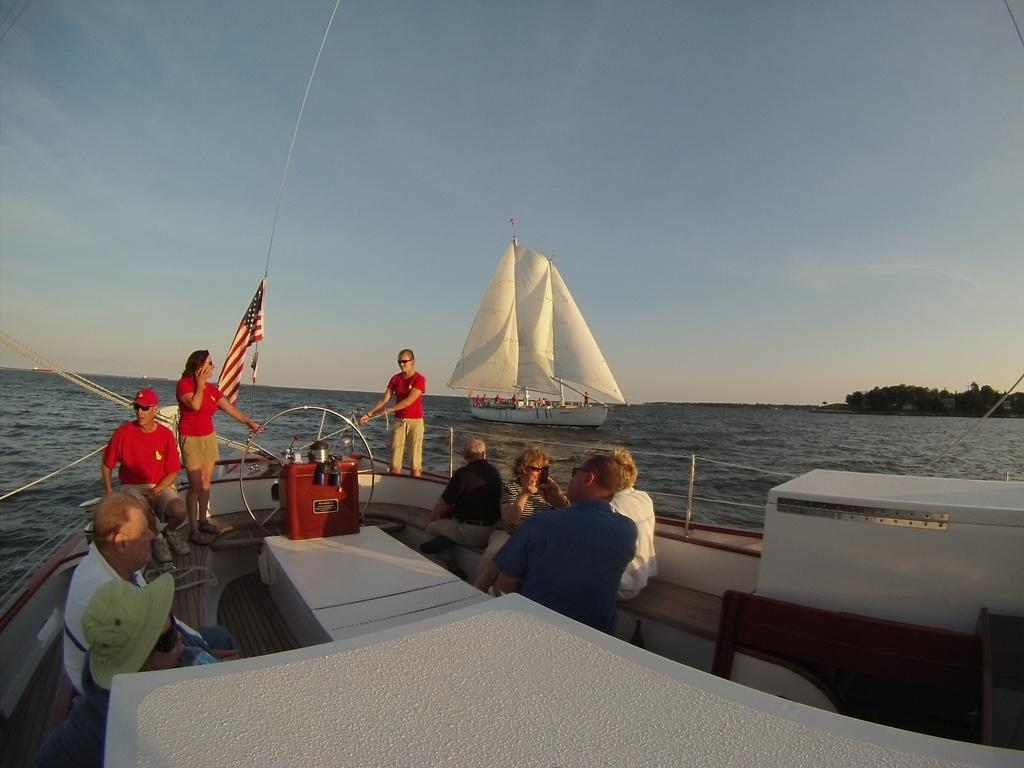Please provide a concise description of this image. In this image I can see a boat and in the boat I can see few persons sitting and few persons standing and a flag. In the background I can see the water, another boat with few persons in it, few trees and the sky. 